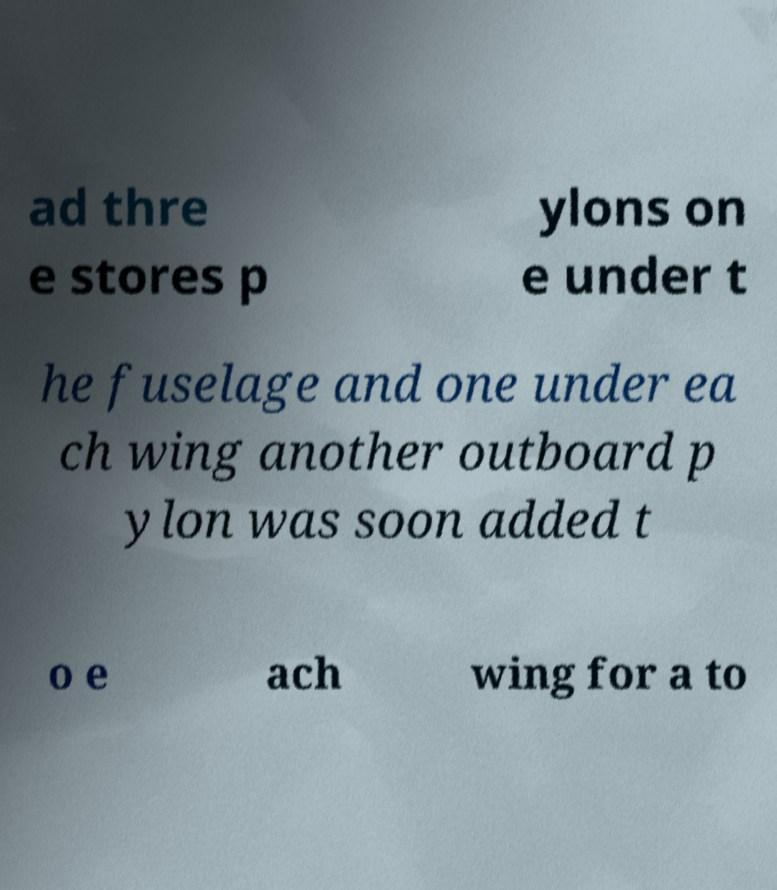What messages or text are displayed in this image? I need them in a readable, typed format. ad thre e stores p ylons on e under t he fuselage and one under ea ch wing another outboard p ylon was soon added t o e ach wing for a to 